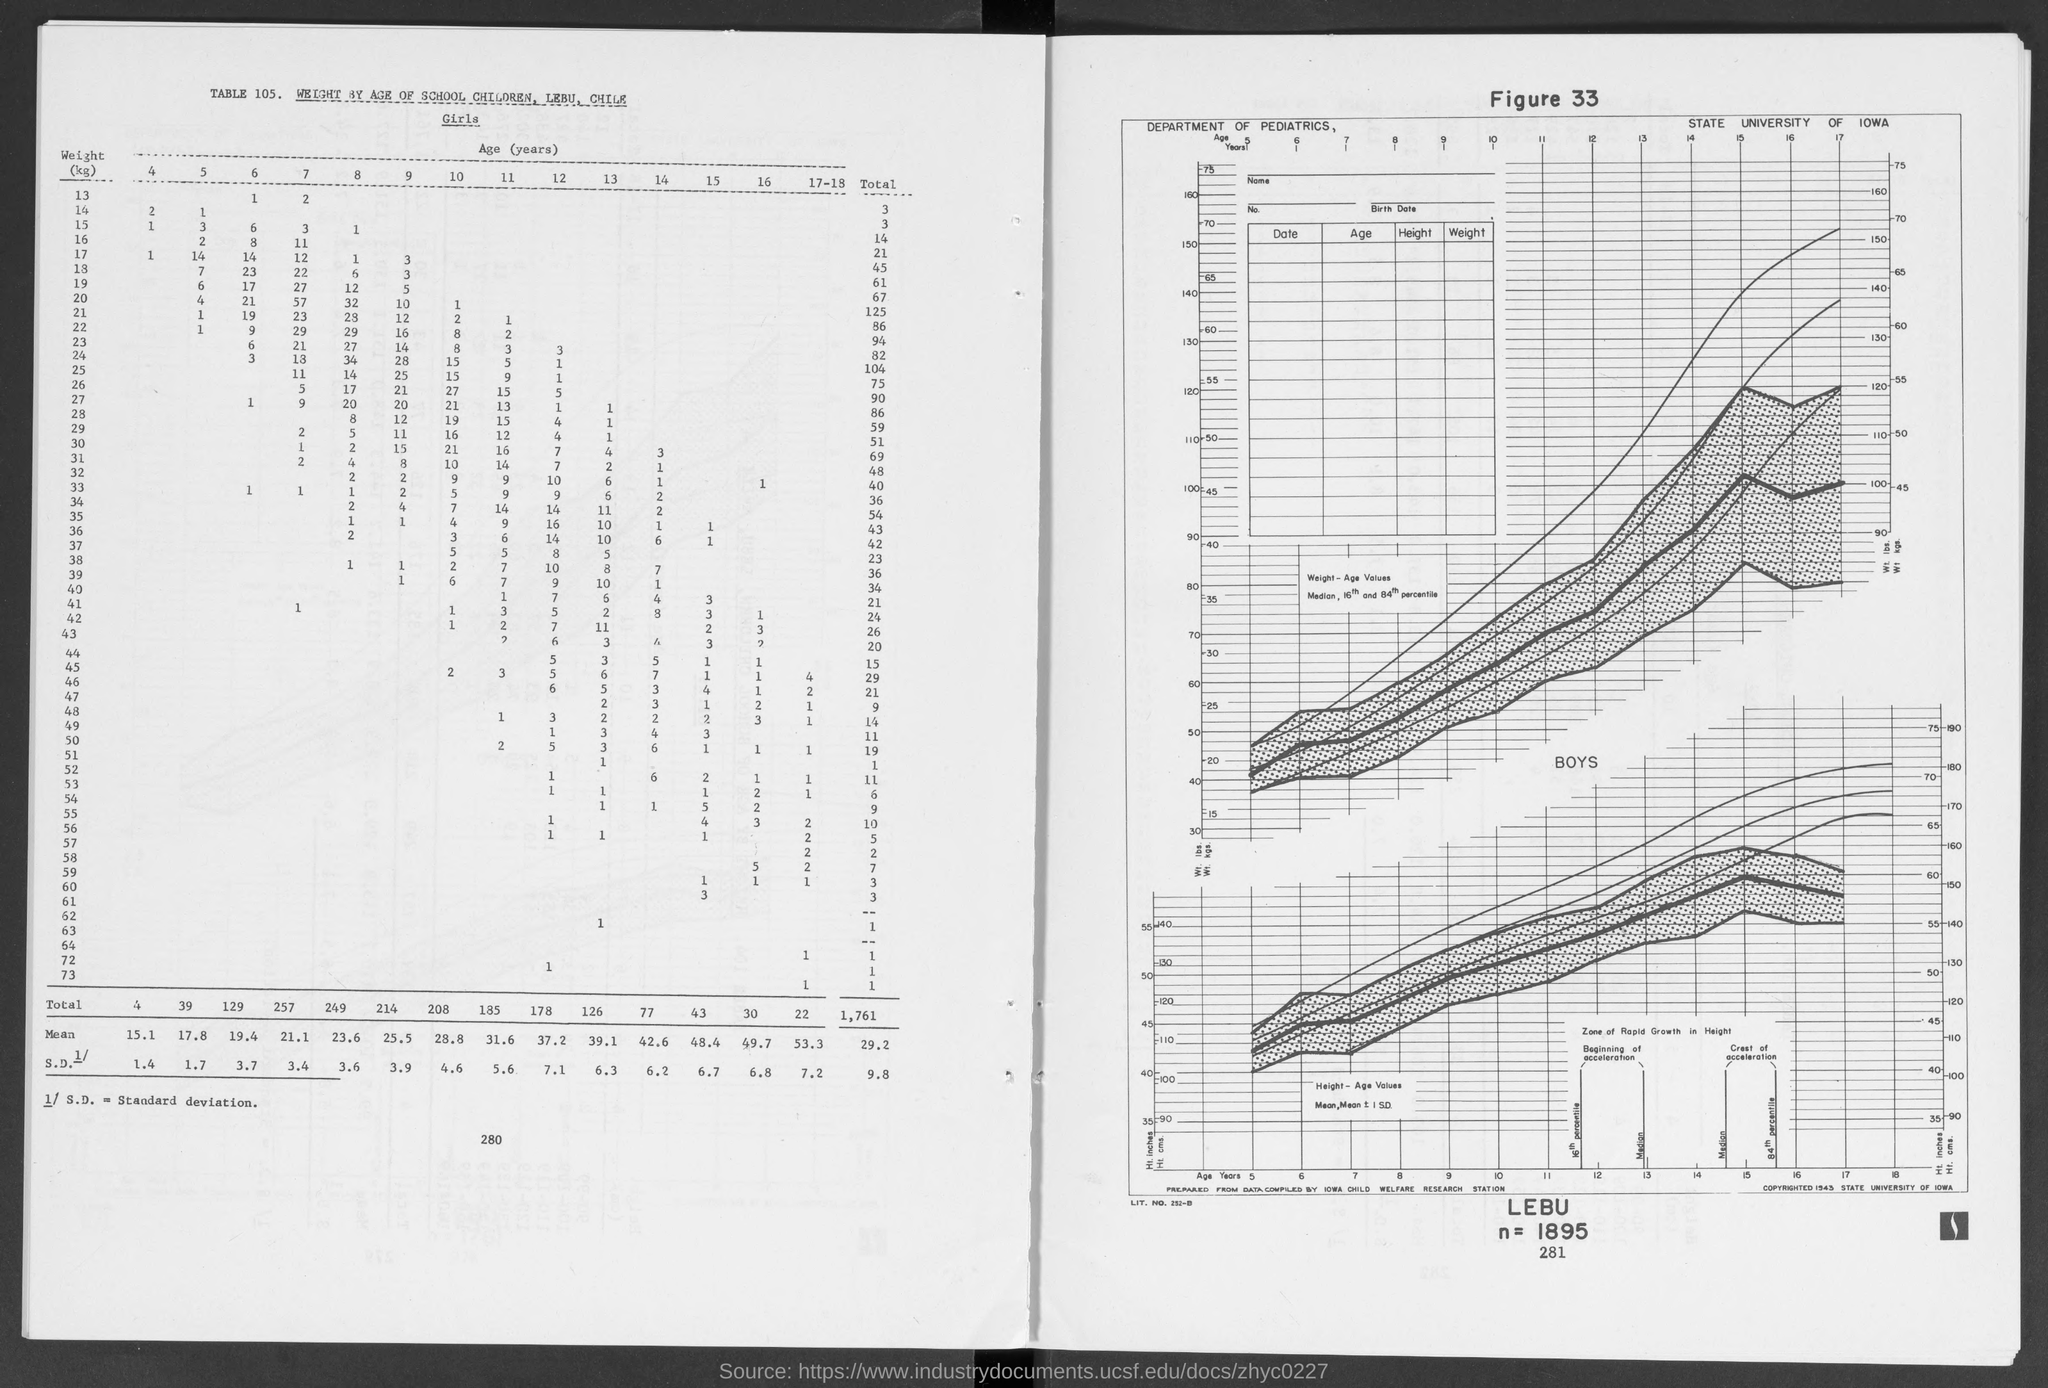What is the total number of girls of weight 13?
Give a very brief answer. 3. What is the number of girls of weight 13 of age 7?
Provide a succinct answer. 2. What is the figure number?
Your answer should be compact. 33. What is the table number?
Your answer should be compact. 105. What is the value of n?
Ensure brevity in your answer.  1895. What is the total number of girls of weight 15?
Make the answer very short. 14. 